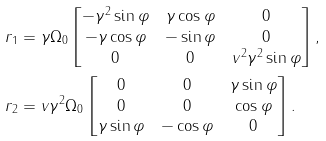Convert formula to latex. <formula><loc_0><loc_0><loc_500><loc_500>r _ { 1 } & = \gamma \Omega _ { 0 } \begin{bmatrix} - \gamma ^ { 2 } \sin \varphi & \gamma \cos \varphi & 0 \\ - \gamma \cos \varphi & - \sin \varphi & 0 \\ 0 & 0 & v ^ { 2 } \gamma ^ { 2 } \sin \varphi \end{bmatrix} , \\ r _ { 2 } & = v \gamma ^ { 2 } \Omega _ { 0 } \begin{bmatrix} 0 & 0 & \gamma \sin \varphi \\ 0 & 0 & \cos \varphi \\ \gamma \sin \varphi & - \cos \varphi & 0 \end{bmatrix} .</formula> 